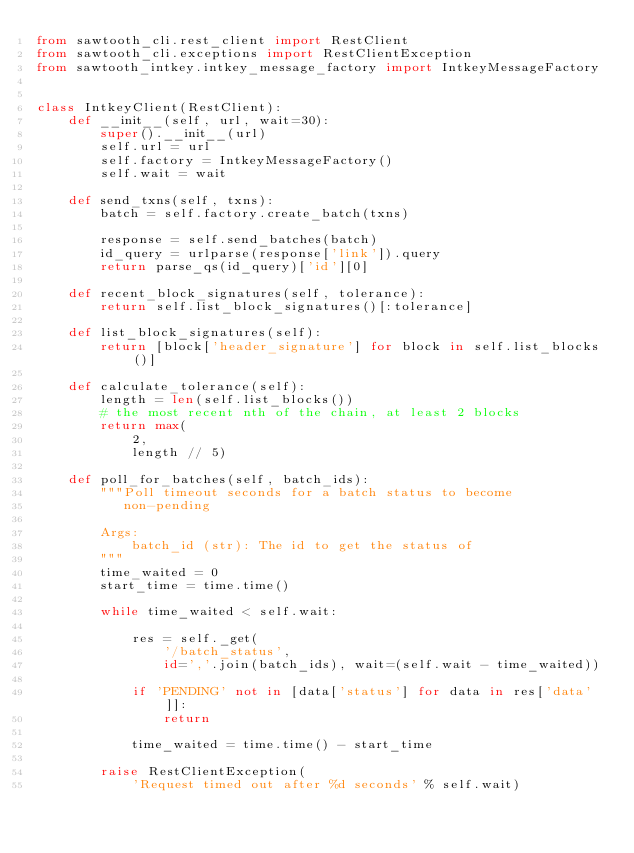<code> <loc_0><loc_0><loc_500><loc_500><_Python_>from sawtooth_cli.rest_client import RestClient
from sawtooth_cli.exceptions import RestClientException
from sawtooth_intkey.intkey_message_factory import IntkeyMessageFactory


class IntkeyClient(RestClient):
    def __init__(self, url, wait=30):
        super().__init__(url)
        self.url = url
        self.factory = IntkeyMessageFactory()
        self.wait = wait

    def send_txns(self, txns):
        batch = self.factory.create_batch(txns)

        response = self.send_batches(batch)
        id_query = urlparse(response['link']).query
        return parse_qs(id_query)['id'][0]

    def recent_block_signatures(self, tolerance):
        return self.list_block_signatures()[:tolerance]

    def list_block_signatures(self):
        return [block['header_signature'] for block in self.list_blocks()]

    def calculate_tolerance(self):
        length = len(self.list_blocks())
        # the most recent nth of the chain, at least 2 blocks
        return max(
            2,
            length // 5)

    def poll_for_batches(self, batch_ids):
        """Poll timeout seconds for a batch status to become
           non-pending

        Args:
            batch_id (str): The id to get the status of
        """
        time_waited = 0
        start_time = time.time()

        while time_waited < self.wait:

            res = self._get(
                '/batch_status',
                id=','.join(batch_ids), wait=(self.wait - time_waited))

            if 'PENDING' not in [data['status'] for data in res['data']]:
                return

            time_waited = time.time() - start_time

        raise RestClientException(
            'Request timed out after %d seconds' % self.wait)
</code> 